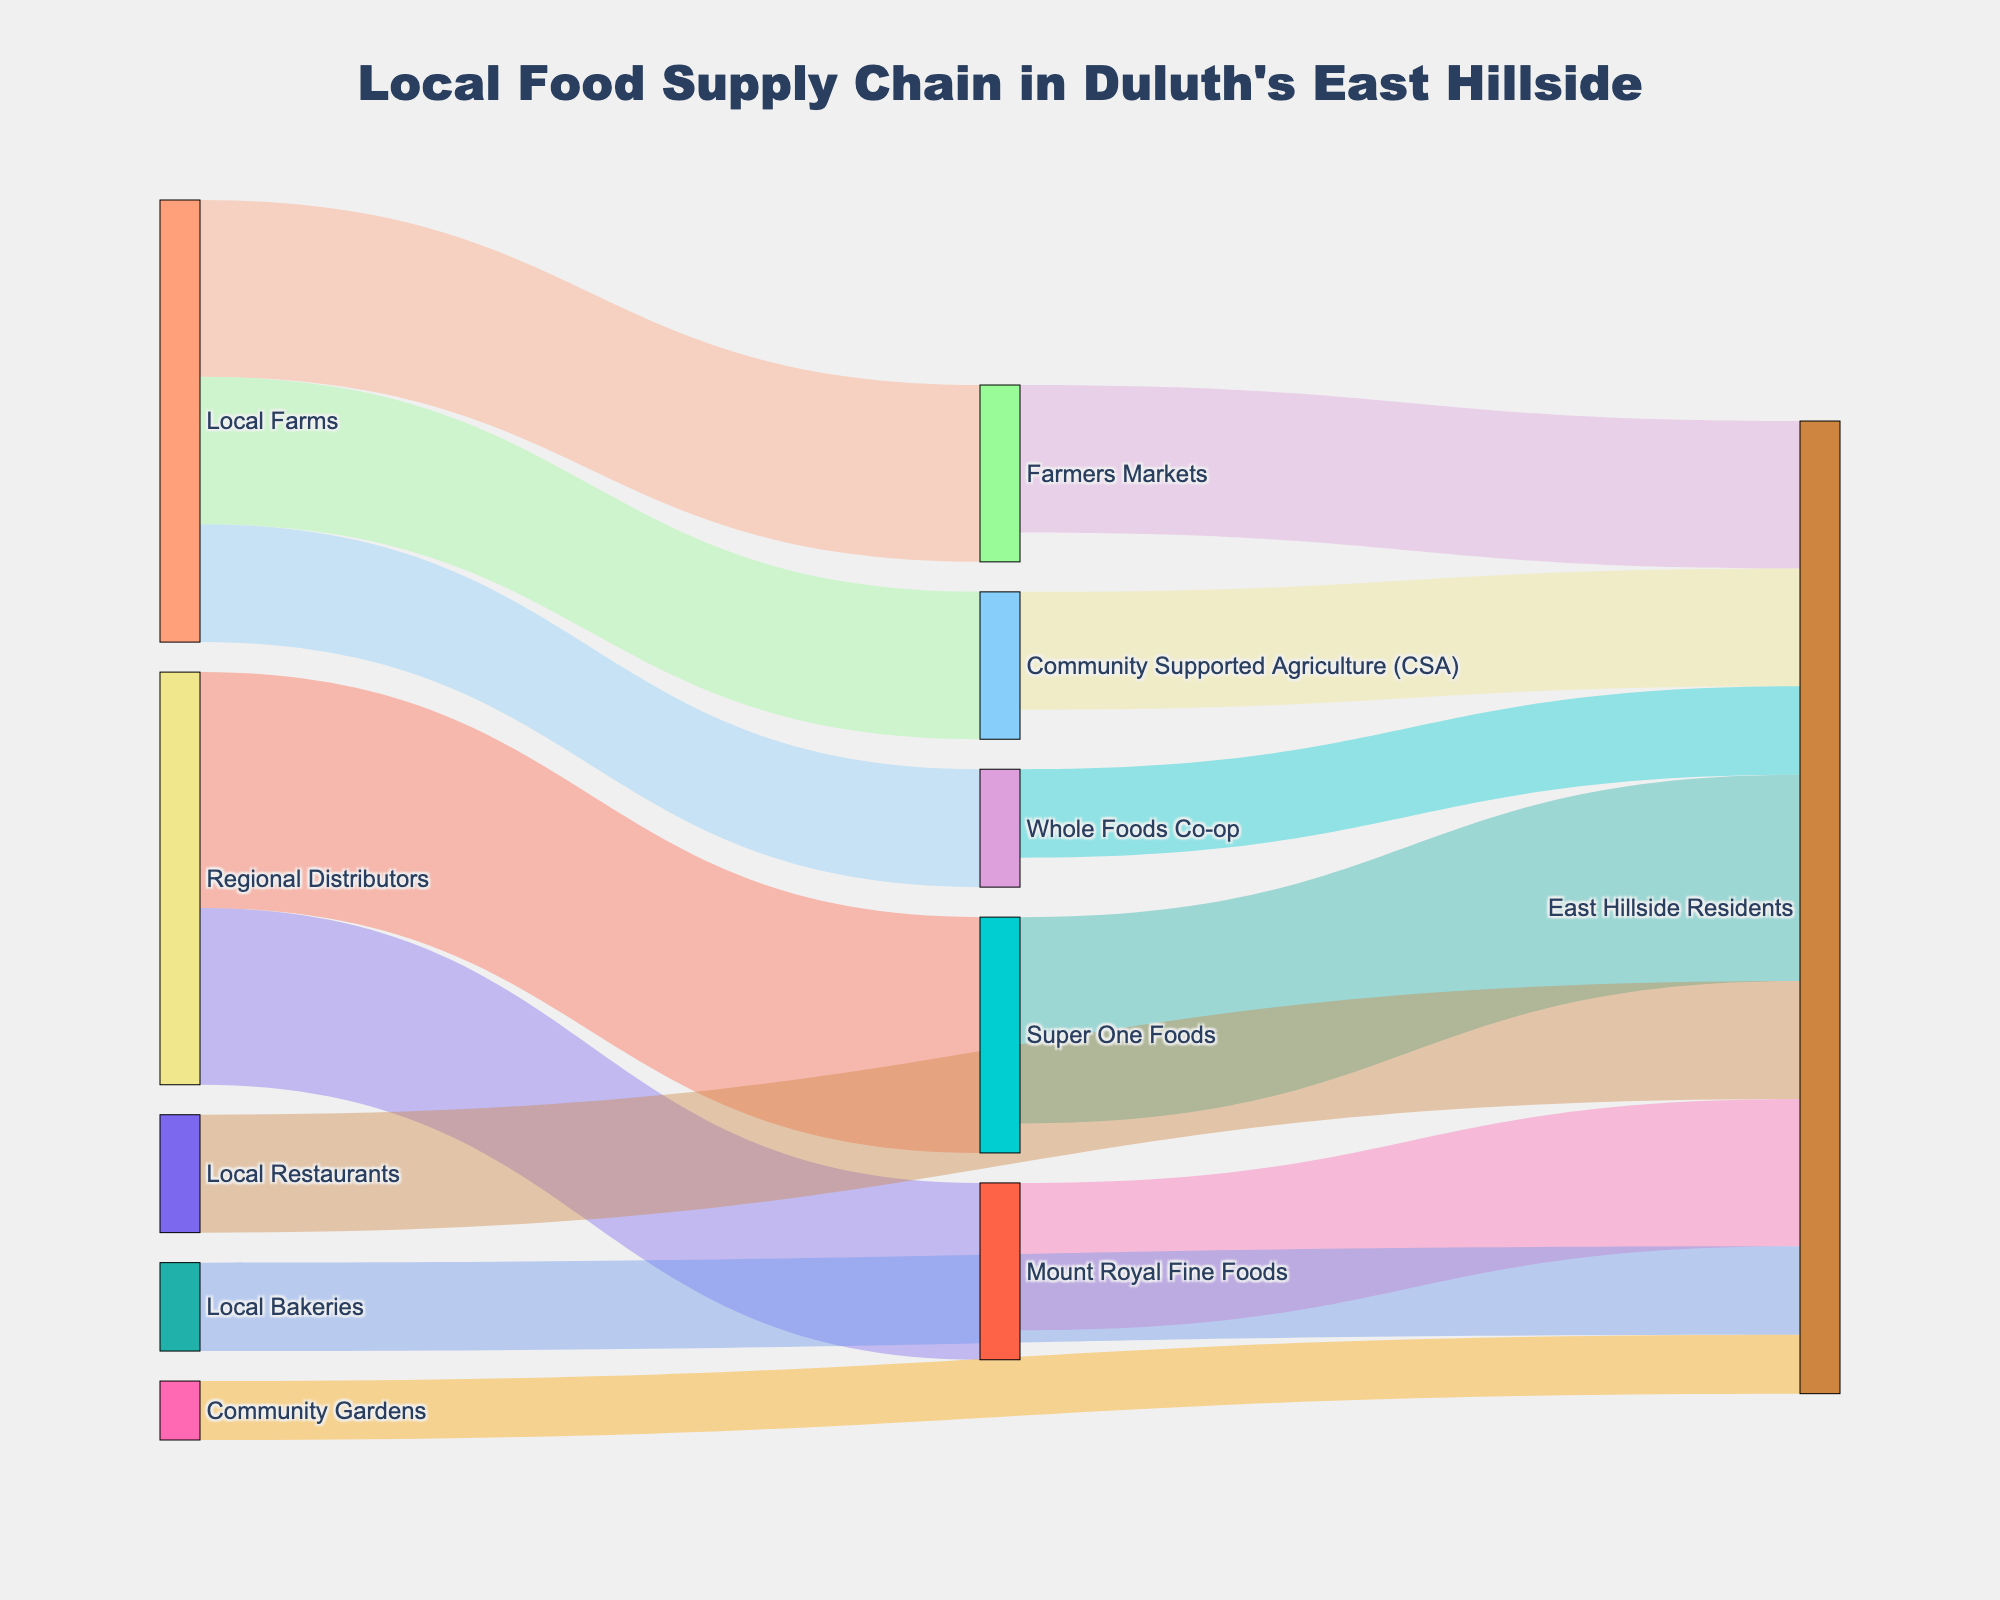What is the title of the figure? The title is displayed at the top of the figure and gives a broad idea about the content represented in the chart.
Answer: Local Food Supply Chain in Duluth's East Hillside Which local suppliers provide directly to East Hillside Residents? By following the arrows leading to "East Hillside Residents," we can identify all the local suppliers.
Answer: Farmers Markets, Community Supported Agriculture (CSA), Whole Foods Co-op, Super One Foods, Mount Royal Fine Foods, Local Restaurants, Local Bakeries, Community Gardens How many units do Local Farms supply to Farmers Markets? The value associated with the link from "Local Farms" to "Farmers Markets" represents the flow in units.
Answer: 30 How does the supply of Whole Foods Co-op compare to Mount Royal Fine Foods in terms of units? Whole Foods Co-op supplies 15 units, whereas Mount Royal Fine Foods supplies 25 units to East Hillside Residents. To compare, Mount Royal Fine Foods supplies 10 units more than Whole Foods Co-op.
Answer: Mount Royal Fine Foods supplies more What is the total supply from Local Farms to their direct targets? Summing the values from Local Farms to each of their targets: 30 (Farmers Markets) + 25 (CSA) + 20 (Whole Foods Co-op) = 75 units.
Answer: 75 units Which supply path has the highest value of units directed to East Hillside Residents? By examining all the flows leading to East Hillside Residents, the path from Super One Foods has the highest value of 35 units.
Answer: Super One Foods How does the contribution of Local Restaurants compare to Local Bakeries to East Hillside Residents? Local Restaurants supply 20 units while Local Bakeries supply 15 units. Local Restaurants supply 5 units more than Local Bakeries.
Answer: Local Restaurants supply more How many units in total are supplied by Regional Distributors? Adding the units supplied by Regional Distributors: 40 (Super One Foods) + 30 (Mount Royal Fine Foods) = 70 units.
Answer: 70 units What is the total number of units that reach East Hillside Residents from all sources? Summing all the units leading to East Hillside Residents: 25 (Farmers Markets) + 20 (CSA) + 15 (Whole Foods Co-op) + 35 (Super One Foods) + 25 (Mount Royal Fine Foods) + 20 (Local Restaurants) + 15 (Local Bakeries) + 10 (Community Gardens) = 165 units.
Answer: 165 units 